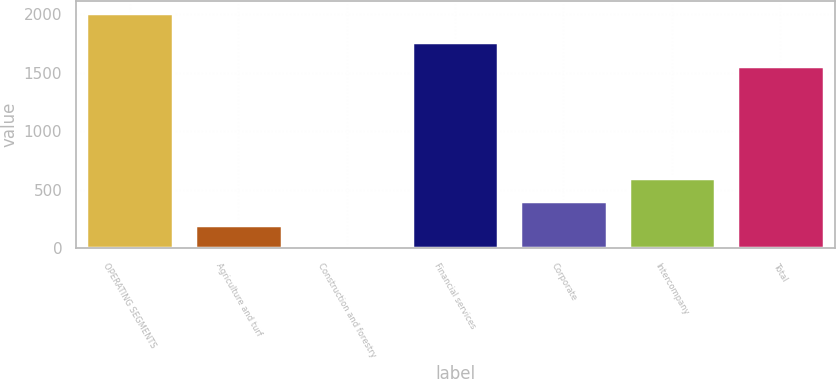<chart> <loc_0><loc_0><loc_500><loc_500><bar_chart><fcel>OPERATING SEGMENTS<fcel>Agriculture and turf<fcel>Construction and forestry<fcel>Financial services<fcel>Corporate<fcel>Intercompany<fcel>Total<nl><fcel>2014<fcel>202.3<fcel>1<fcel>1762.3<fcel>403.6<fcel>604.9<fcel>1561<nl></chart> 